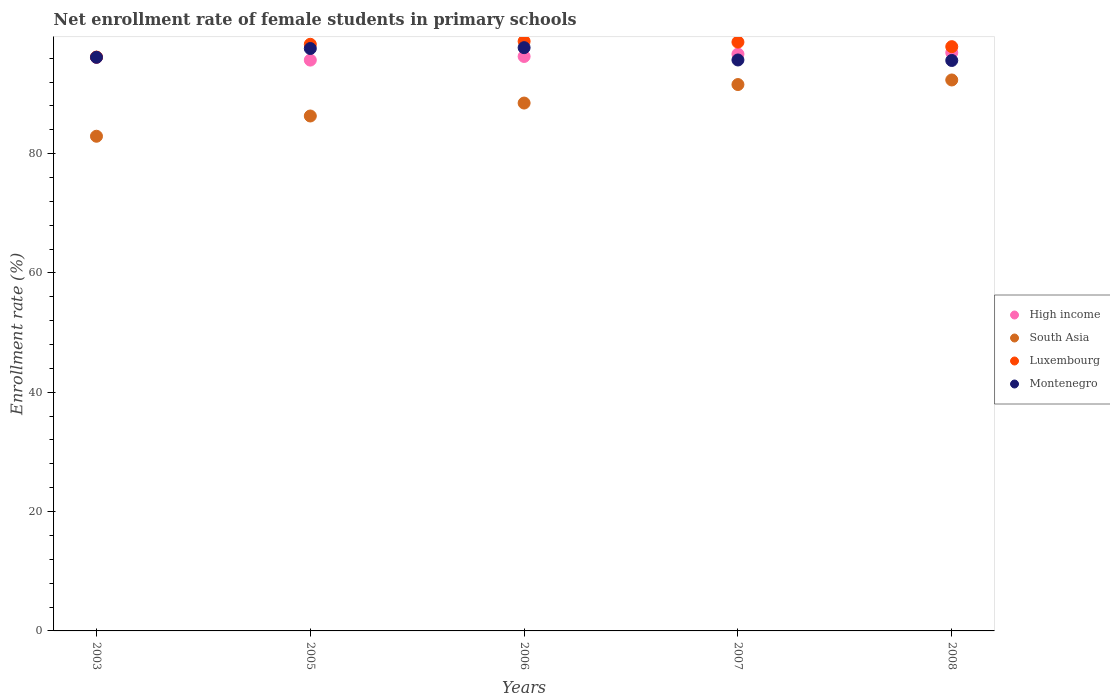How many different coloured dotlines are there?
Offer a very short reply. 4. Is the number of dotlines equal to the number of legend labels?
Your response must be concise. Yes. What is the net enrollment rate of female students in primary schools in Montenegro in 2008?
Ensure brevity in your answer.  95.61. Across all years, what is the maximum net enrollment rate of female students in primary schools in High income?
Your answer should be very brief. 96.92. Across all years, what is the minimum net enrollment rate of female students in primary schools in Montenegro?
Offer a terse response. 95.61. What is the total net enrollment rate of female students in primary schools in High income in the graph?
Your answer should be compact. 481.69. What is the difference between the net enrollment rate of female students in primary schools in Luxembourg in 2003 and that in 2006?
Provide a short and direct response. -2.64. What is the difference between the net enrollment rate of female students in primary schools in High income in 2006 and the net enrollment rate of female students in primary schools in Montenegro in 2007?
Provide a short and direct response. 0.59. What is the average net enrollment rate of female students in primary schools in Montenegro per year?
Your response must be concise. 96.56. In the year 2007, what is the difference between the net enrollment rate of female students in primary schools in Luxembourg and net enrollment rate of female students in primary schools in High income?
Offer a very short reply. 2.01. What is the ratio of the net enrollment rate of female students in primary schools in Luxembourg in 2006 to that in 2007?
Your answer should be compact. 1. Is the net enrollment rate of female students in primary schools in Montenegro in 2006 less than that in 2007?
Give a very brief answer. No. Is the difference between the net enrollment rate of female students in primary schools in Luxembourg in 2005 and 2006 greater than the difference between the net enrollment rate of female students in primary schools in High income in 2005 and 2006?
Make the answer very short. Yes. What is the difference between the highest and the second highest net enrollment rate of female students in primary schools in South Asia?
Offer a terse response. 0.77. What is the difference between the highest and the lowest net enrollment rate of female students in primary schools in High income?
Make the answer very short. 1.25. Is the sum of the net enrollment rate of female students in primary schools in Luxembourg in 2006 and 2008 greater than the maximum net enrollment rate of female students in primary schools in High income across all years?
Give a very brief answer. Yes. Is it the case that in every year, the sum of the net enrollment rate of female students in primary schools in Montenegro and net enrollment rate of female students in primary schools in High income  is greater than the sum of net enrollment rate of female students in primary schools in Luxembourg and net enrollment rate of female students in primary schools in South Asia?
Your answer should be very brief. Yes. Does the net enrollment rate of female students in primary schools in Montenegro monotonically increase over the years?
Provide a short and direct response. No. How many dotlines are there?
Your answer should be very brief. 4. What is the difference between two consecutive major ticks on the Y-axis?
Keep it short and to the point. 20. Are the values on the major ticks of Y-axis written in scientific E-notation?
Provide a succinct answer. No. Does the graph contain any zero values?
Offer a very short reply. No. Does the graph contain grids?
Make the answer very short. No. Where does the legend appear in the graph?
Keep it short and to the point. Center right. What is the title of the graph?
Provide a short and direct response. Net enrollment rate of female students in primary schools. Does "Guinea-Bissau" appear as one of the legend labels in the graph?
Your answer should be very brief. No. What is the label or title of the X-axis?
Offer a terse response. Years. What is the label or title of the Y-axis?
Keep it short and to the point. Enrollment rate (%). What is the Enrollment rate (%) of High income in 2003?
Provide a short and direct response. 96.13. What is the Enrollment rate (%) of South Asia in 2003?
Your answer should be very brief. 82.91. What is the Enrollment rate (%) of Luxembourg in 2003?
Offer a terse response. 96.18. What is the Enrollment rate (%) in Montenegro in 2003?
Provide a succinct answer. 96.14. What is the Enrollment rate (%) in High income in 2005?
Provide a short and direct response. 95.67. What is the Enrollment rate (%) of South Asia in 2005?
Offer a terse response. 86.3. What is the Enrollment rate (%) in Luxembourg in 2005?
Make the answer very short. 98.32. What is the Enrollment rate (%) of Montenegro in 2005?
Your answer should be very brief. 97.61. What is the Enrollment rate (%) of High income in 2006?
Provide a succinct answer. 96.28. What is the Enrollment rate (%) of South Asia in 2006?
Keep it short and to the point. 88.47. What is the Enrollment rate (%) in Luxembourg in 2006?
Keep it short and to the point. 98.82. What is the Enrollment rate (%) of Montenegro in 2006?
Provide a short and direct response. 97.76. What is the Enrollment rate (%) of High income in 2007?
Offer a very short reply. 96.68. What is the Enrollment rate (%) in South Asia in 2007?
Offer a terse response. 91.57. What is the Enrollment rate (%) of Luxembourg in 2007?
Offer a very short reply. 98.69. What is the Enrollment rate (%) of Montenegro in 2007?
Make the answer very short. 95.69. What is the Enrollment rate (%) in High income in 2008?
Your answer should be very brief. 96.92. What is the Enrollment rate (%) in South Asia in 2008?
Your answer should be compact. 92.34. What is the Enrollment rate (%) in Luxembourg in 2008?
Give a very brief answer. 97.92. What is the Enrollment rate (%) in Montenegro in 2008?
Provide a succinct answer. 95.61. Across all years, what is the maximum Enrollment rate (%) of High income?
Your answer should be very brief. 96.92. Across all years, what is the maximum Enrollment rate (%) of South Asia?
Offer a terse response. 92.34. Across all years, what is the maximum Enrollment rate (%) of Luxembourg?
Provide a short and direct response. 98.82. Across all years, what is the maximum Enrollment rate (%) of Montenegro?
Offer a very short reply. 97.76. Across all years, what is the minimum Enrollment rate (%) in High income?
Keep it short and to the point. 95.67. Across all years, what is the minimum Enrollment rate (%) in South Asia?
Give a very brief answer. 82.91. Across all years, what is the minimum Enrollment rate (%) of Luxembourg?
Provide a short and direct response. 96.18. Across all years, what is the minimum Enrollment rate (%) of Montenegro?
Provide a short and direct response. 95.61. What is the total Enrollment rate (%) in High income in the graph?
Give a very brief answer. 481.69. What is the total Enrollment rate (%) of South Asia in the graph?
Your response must be concise. 441.6. What is the total Enrollment rate (%) in Luxembourg in the graph?
Offer a very short reply. 489.93. What is the total Enrollment rate (%) in Montenegro in the graph?
Make the answer very short. 482.81. What is the difference between the Enrollment rate (%) of High income in 2003 and that in 2005?
Offer a terse response. 0.46. What is the difference between the Enrollment rate (%) in South Asia in 2003 and that in 2005?
Offer a very short reply. -3.39. What is the difference between the Enrollment rate (%) in Luxembourg in 2003 and that in 2005?
Provide a short and direct response. -2.14. What is the difference between the Enrollment rate (%) of Montenegro in 2003 and that in 2005?
Provide a short and direct response. -1.47. What is the difference between the Enrollment rate (%) of High income in 2003 and that in 2006?
Offer a very short reply. -0.15. What is the difference between the Enrollment rate (%) of South Asia in 2003 and that in 2006?
Provide a succinct answer. -5.56. What is the difference between the Enrollment rate (%) of Luxembourg in 2003 and that in 2006?
Your answer should be very brief. -2.64. What is the difference between the Enrollment rate (%) in Montenegro in 2003 and that in 2006?
Ensure brevity in your answer.  -1.61. What is the difference between the Enrollment rate (%) in High income in 2003 and that in 2007?
Your answer should be very brief. -0.55. What is the difference between the Enrollment rate (%) of South Asia in 2003 and that in 2007?
Your response must be concise. -8.67. What is the difference between the Enrollment rate (%) in Luxembourg in 2003 and that in 2007?
Offer a very short reply. -2.51. What is the difference between the Enrollment rate (%) in Montenegro in 2003 and that in 2007?
Give a very brief answer. 0.45. What is the difference between the Enrollment rate (%) in High income in 2003 and that in 2008?
Provide a short and direct response. -0.78. What is the difference between the Enrollment rate (%) of South Asia in 2003 and that in 2008?
Give a very brief answer. -9.43. What is the difference between the Enrollment rate (%) in Luxembourg in 2003 and that in 2008?
Offer a very short reply. -1.75. What is the difference between the Enrollment rate (%) of Montenegro in 2003 and that in 2008?
Keep it short and to the point. 0.53. What is the difference between the Enrollment rate (%) of High income in 2005 and that in 2006?
Provide a succinct answer. -0.61. What is the difference between the Enrollment rate (%) in South Asia in 2005 and that in 2006?
Offer a terse response. -2.17. What is the difference between the Enrollment rate (%) of Luxembourg in 2005 and that in 2006?
Keep it short and to the point. -0.5. What is the difference between the Enrollment rate (%) of Montenegro in 2005 and that in 2006?
Provide a short and direct response. -0.14. What is the difference between the Enrollment rate (%) of High income in 2005 and that in 2007?
Provide a short and direct response. -1.01. What is the difference between the Enrollment rate (%) of South Asia in 2005 and that in 2007?
Give a very brief answer. -5.27. What is the difference between the Enrollment rate (%) of Luxembourg in 2005 and that in 2007?
Your response must be concise. -0.37. What is the difference between the Enrollment rate (%) of Montenegro in 2005 and that in 2007?
Offer a very short reply. 1.92. What is the difference between the Enrollment rate (%) in High income in 2005 and that in 2008?
Offer a very short reply. -1.25. What is the difference between the Enrollment rate (%) of South Asia in 2005 and that in 2008?
Your response must be concise. -6.04. What is the difference between the Enrollment rate (%) in Luxembourg in 2005 and that in 2008?
Provide a short and direct response. 0.4. What is the difference between the Enrollment rate (%) of Montenegro in 2005 and that in 2008?
Keep it short and to the point. 2. What is the difference between the Enrollment rate (%) in High income in 2006 and that in 2007?
Make the answer very short. -0.4. What is the difference between the Enrollment rate (%) of South Asia in 2006 and that in 2007?
Keep it short and to the point. -3.1. What is the difference between the Enrollment rate (%) of Luxembourg in 2006 and that in 2007?
Your answer should be very brief. 0.13. What is the difference between the Enrollment rate (%) of Montenegro in 2006 and that in 2007?
Offer a terse response. 2.06. What is the difference between the Enrollment rate (%) in High income in 2006 and that in 2008?
Keep it short and to the point. -0.64. What is the difference between the Enrollment rate (%) in South Asia in 2006 and that in 2008?
Provide a succinct answer. -3.87. What is the difference between the Enrollment rate (%) of Luxembourg in 2006 and that in 2008?
Your answer should be compact. 0.89. What is the difference between the Enrollment rate (%) in Montenegro in 2006 and that in 2008?
Provide a short and direct response. 2.15. What is the difference between the Enrollment rate (%) of High income in 2007 and that in 2008?
Your response must be concise. -0.24. What is the difference between the Enrollment rate (%) in South Asia in 2007 and that in 2008?
Provide a succinct answer. -0.77. What is the difference between the Enrollment rate (%) in Luxembourg in 2007 and that in 2008?
Your answer should be compact. 0.76. What is the difference between the Enrollment rate (%) of Montenegro in 2007 and that in 2008?
Offer a very short reply. 0.08. What is the difference between the Enrollment rate (%) in High income in 2003 and the Enrollment rate (%) in South Asia in 2005?
Your answer should be compact. 9.83. What is the difference between the Enrollment rate (%) in High income in 2003 and the Enrollment rate (%) in Luxembourg in 2005?
Offer a very short reply. -2.19. What is the difference between the Enrollment rate (%) of High income in 2003 and the Enrollment rate (%) of Montenegro in 2005?
Your answer should be very brief. -1.48. What is the difference between the Enrollment rate (%) in South Asia in 2003 and the Enrollment rate (%) in Luxembourg in 2005?
Offer a terse response. -15.41. What is the difference between the Enrollment rate (%) in South Asia in 2003 and the Enrollment rate (%) in Montenegro in 2005?
Your answer should be very brief. -14.7. What is the difference between the Enrollment rate (%) of Luxembourg in 2003 and the Enrollment rate (%) of Montenegro in 2005?
Your answer should be compact. -1.44. What is the difference between the Enrollment rate (%) in High income in 2003 and the Enrollment rate (%) in South Asia in 2006?
Give a very brief answer. 7.66. What is the difference between the Enrollment rate (%) of High income in 2003 and the Enrollment rate (%) of Luxembourg in 2006?
Give a very brief answer. -2.68. What is the difference between the Enrollment rate (%) in High income in 2003 and the Enrollment rate (%) in Montenegro in 2006?
Make the answer very short. -1.62. What is the difference between the Enrollment rate (%) of South Asia in 2003 and the Enrollment rate (%) of Luxembourg in 2006?
Give a very brief answer. -15.91. What is the difference between the Enrollment rate (%) in South Asia in 2003 and the Enrollment rate (%) in Montenegro in 2006?
Your answer should be compact. -14.85. What is the difference between the Enrollment rate (%) in Luxembourg in 2003 and the Enrollment rate (%) in Montenegro in 2006?
Make the answer very short. -1.58. What is the difference between the Enrollment rate (%) of High income in 2003 and the Enrollment rate (%) of South Asia in 2007?
Make the answer very short. 4.56. What is the difference between the Enrollment rate (%) in High income in 2003 and the Enrollment rate (%) in Luxembourg in 2007?
Keep it short and to the point. -2.55. What is the difference between the Enrollment rate (%) of High income in 2003 and the Enrollment rate (%) of Montenegro in 2007?
Offer a terse response. 0.44. What is the difference between the Enrollment rate (%) of South Asia in 2003 and the Enrollment rate (%) of Luxembourg in 2007?
Provide a succinct answer. -15.78. What is the difference between the Enrollment rate (%) in South Asia in 2003 and the Enrollment rate (%) in Montenegro in 2007?
Your answer should be compact. -12.78. What is the difference between the Enrollment rate (%) of Luxembourg in 2003 and the Enrollment rate (%) of Montenegro in 2007?
Provide a succinct answer. 0.49. What is the difference between the Enrollment rate (%) in High income in 2003 and the Enrollment rate (%) in South Asia in 2008?
Your response must be concise. 3.79. What is the difference between the Enrollment rate (%) of High income in 2003 and the Enrollment rate (%) of Luxembourg in 2008?
Provide a short and direct response. -1.79. What is the difference between the Enrollment rate (%) of High income in 2003 and the Enrollment rate (%) of Montenegro in 2008?
Make the answer very short. 0.53. What is the difference between the Enrollment rate (%) in South Asia in 2003 and the Enrollment rate (%) in Luxembourg in 2008?
Ensure brevity in your answer.  -15.02. What is the difference between the Enrollment rate (%) in South Asia in 2003 and the Enrollment rate (%) in Montenegro in 2008?
Ensure brevity in your answer.  -12.7. What is the difference between the Enrollment rate (%) in Luxembourg in 2003 and the Enrollment rate (%) in Montenegro in 2008?
Your response must be concise. 0.57. What is the difference between the Enrollment rate (%) in High income in 2005 and the Enrollment rate (%) in South Asia in 2006?
Provide a short and direct response. 7.2. What is the difference between the Enrollment rate (%) in High income in 2005 and the Enrollment rate (%) in Luxembourg in 2006?
Keep it short and to the point. -3.15. What is the difference between the Enrollment rate (%) in High income in 2005 and the Enrollment rate (%) in Montenegro in 2006?
Offer a terse response. -2.09. What is the difference between the Enrollment rate (%) in South Asia in 2005 and the Enrollment rate (%) in Luxembourg in 2006?
Your answer should be compact. -12.52. What is the difference between the Enrollment rate (%) in South Asia in 2005 and the Enrollment rate (%) in Montenegro in 2006?
Offer a terse response. -11.45. What is the difference between the Enrollment rate (%) in Luxembourg in 2005 and the Enrollment rate (%) in Montenegro in 2006?
Ensure brevity in your answer.  0.57. What is the difference between the Enrollment rate (%) of High income in 2005 and the Enrollment rate (%) of South Asia in 2007?
Ensure brevity in your answer.  4.1. What is the difference between the Enrollment rate (%) in High income in 2005 and the Enrollment rate (%) in Luxembourg in 2007?
Offer a very short reply. -3.02. What is the difference between the Enrollment rate (%) of High income in 2005 and the Enrollment rate (%) of Montenegro in 2007?
Provide a succinct answer. -0.02. What is the difference between the Enrollment rate (%) of South Asia in 2005 and the Enrollment rate (%) of Luxembourg in 2007?
Offer a very short reply. -12.38. What is the difference between the Enrollment rate (%) of South Asia in 2005 and the Enrollment rate (%) of Montenegro in 2007?
Ensure brevity in your answer.  -9.39. What is the difference between the Enrollment rate (%) of Luxembourg in 2005 and the Enrollment rate (%) of Montenegro in 2007?
Offer a terse response. 2.63. What is the difference between the Enrollment rate (%) in High income in 2005 and the Enrollment rate (%) in South Asia in 2008?
Your answer should be compact. 3.33. What is the difference between the Enrollment rate (%) in High income in 2005 and the Enrollment rate (%) in Luxembourg in 2008?
Your response must be concise. -2.25. What is the difference between the Enrollment rate (%) in High income in 2005 and the Enrollment rate (%) in Montenegro in 2008?
Give a very brief answer. 0.06. What is the difference between the Enrollment rate (%) of South Asia in 2005 and the Enrollment rate (%) of Luxembourg in 2008?
Offer a very short reply. -11.62. What is the difference between the Enrollment rate (%) in South Asia in 2005 and the Enrollment rate (%) in Montenegro in 2008?
Offer a terse response. -9.31. What is the difference between the Enrollment rate (%) in Luxembourg in 2005 and the Enrollment rate (%) in Montenegro in 2008?
Offer a very short reply. 2.71. What is the difference between the Enrollment rate (%) of High income in 2006 and the Enrollment rate (%) of South Asia in 2007?
Keep it short and to the point. 4.71. What is the difference between the Enrollment rate (%) of High income in 2006 and the Enrollment rate (%) of Luxembourg in 2007?
Offer a terse response. -2.41. What is the difference between the Enrollment rate (%) of High income in 2006 and the Enrollment rate (%) of Montenegro in 2007?
Your answer should be compact. 0.59. What is the difference between the Enrollment rate (%) of South Asia in 2006 and the Enrollment rate (%) of Luxembourg in 2007?
Give a very brief answer. -10.21. What is the difference between the Enrollment rate (%) of South Asia in 2006 and the Enrollment rate (%) of Montenegro in 2007?
Offer a terse response. -7.22. What is the difference between the Enrollment rate (%) of Luxembourg in 2006 and the Enrollment rate (%) of Montenegro in 2007?
Keep it short and to the point. 3.13. What is the difference between the Enrollment rate (%) in High income in 2006 and the Enrollment rate (%) in South Asia in 2008?
Give a very brief answer. 3.94. What is the difference between the Enrollment rate (%) in High income in 2006 and the Enrollment rate (%) in Luxembourg in 2008?
Provide a short and direct response. -1.64. What is the difference between the Enrollment rate (%) in High income in 2006 and the Enrollment rate (%) in Montenegro in 2008?
Give a very brief answer. 0.67. What is the difference between the Enrollment rate (%) in South Asia in 2006 and the Enrollment rate (%) in Luxembourg in 2008?
Ensure brevity in your answer.  -9.45. What is the difference between the Enrollment rate (%) in South Asia in 2006 and the Enrollment rate (%) in Montenegro in 2008?
Make the answer very short. -7.14. What is the difference between the Enrollment rate (%) in Luxembourg in 2006 and the Enrollment rate (%) in Montenegro in 2008?
Ensure brevity in your answer.  3.21. What is the difference between the Enrollment rate (%) in High income in 2007 and the Enrollment rate (%) in South Asia in 2008?
Make the answer very short. 4.34. What is the difference between the Enrollment rate (%) of High income in 2007 and the Enrollment rate (%) of Luxembourg in 2008?
Your response must be concise. -1.24. What is the difference between the Enrollment rate (%) of High income in 2007 and the Enrollment rate (%) of Montenegro in 2008?
Your response must be concise. 1.07. What is the difference between the Enrollment rate (%) of South Asia in 2007 and the Enrollment rate (%) of Luxembourg in 2008?
Provide a succinct answer. -6.35. What is the difference between the Enrollment rate (%) of South Asia in 2007 and the Enrollment rate (%) of Montenegro in 2008?
Offer a very short reply. -4.03. What is the difference between the Enrollment rate (%) of Luxembourg in 2007 and the Enrollment rate (%) of Montenegro in 2008?
Ensure brevity in your answer.  3.08. What is the average Enrollment rate (%) in High income per year?
Keep it short and to the point. 96.34. What is the average Enrollment rate (%) in South Asia per year?
Your response must be concise. 88.32. What is the average Enrollment rate (%) in Luxembourg per year?
Your response must be concise. 97.99. What is the average Enrollment rate (%) of Montenegro per year?
Provide a short and direct response. 96.56. In the year 2003, what is the difference between the Enrollment rate (%) of High income and Enrollment rate (%) of South Asia?
Your response must be concise. 13.23. In the year 2003, what is the difference between the Enrollment rate (%) of High income and Enrollment rate (%) of Luxembourg?
Give a very brief answer. -0.04. In the year 2003, what is the difference between the Enrollment rate (%) in High income and Enrollment rate (%) in Montenegro?
Give a very brief answer. -0.01. In the year 2003, what is the difference between the Enrollment rate (%) of South Asia and Enrollment rate (%) of Luxembourg?
Provide a short and direct response. -13.27. In the year 2003, what is the difference between the Enrollment rate (%) in South Asia and Enrollment rate (%) in Montenegro?
Give a very brief answer. -13.23. In the year 2003, what is the difference between the Enrollment rate (%) in Luxembourg and Enrollment rate (%) in Montenegro?
Provide a short and direct response. 0.04. In the year 2005, what is the difference between the Enrollment rate (%) of High income and Enrollment rate (%) of South Asia?
Ensure brevity in your answer.  9.37. In the year 2005, what is the difference between the Enrollment rate (%) in High income and Enrollment rate (%) in Luxembourg?
Offer a very short reply. -2.65. In the year 2005, what is the difference between the Enrollment rate (%) of High income and Enrollment rate (%) of Montenegro?
Provide a succinct answer. -1.94. In the year 2005, what is the difference between the Enrollment rate (%) in South Asia and Enrollment rate (%) in Luxembourg?
Make the answer very short. -12.02. In the year 2005, what is the difference between the Enrollment rate (%) of South Asia and Enrollment rate (%) of Montenegro?
Give a very brief answer. -11.31. In the year 2005, what is the difference between the Enrollment rate (%) of Luxembourg and Enrollment rate (%) of Montenegro?
Your answer should be compact. 0.71. In the year 2006, what is the difference between the Enrollment rate (%) in High income and Enrollment rate (%) in South Asia?
Your response must be concise. 7.81. In the year 2006, what is the difference between the Enrollment rate (%) of High income and Enrollment rate (%) of Luxembourg?
Offer a very short reply. -2.54. In the year 2006, what is the difference between the Enrollment rate (%) of High income and Enrollment rate (%) of Montenegro?
Your answer should be compact. -1.47. In the year 2006, what is the difference between the Enrollment rate (%) in South Asia and Enrollment rate (%) in Luxembourg?
Offer a terse response. -10.35. In the year 2006, what is the difference between the Enrollment rate (%) in South Asia and Enrollment rate (%) in Montenegro?
Your answer should be very brief. -9.28. In the year 2006, what is the difference between the Enrollment rate (%) of Luxembourg and Enrollment rate (%) of Montenegro?
Make the answer very short. 1.06. In the year 2007, what is the difference between the Enrollment rate (%) of High income and Enrollment rate (%) of South Asia?
Provide a succinct answer. 5.11. In the year 2007, what is the difference between the Enrollment rate (%) of High income and Enrollment rate (%) of Luxembourg?
Offer a very short reply. -2.01. In the year 2007, what is the difference between the Enrollment rate (%) in High income and Enrollment rate (%) in Montenegro?
Provide a short and direct response. 0.99. In the year 2007, what is the difference between the Enrollment rate (%) in South Asia and Enrollment rate (%) in Luxembourg?
Make the answer very short. -7.11. In the year 2007, what is the difference between the Enrollment rate (%) of South Asia and Enrollment rate (%) of Montenegro?
Provide a short and direct response. -4.12. In the year 2007, what is the difference between the Enrollment rate (%) in Luxembourg and Enrollment rate (%) in Montenegro?
Offer a terse response. 3. In the year 2008, what is the difference between the Enrollment rate (%) of High income and Enrollment rate (%) of South Asia?
Ensure brevity in your answer.  4.58. In the year 2008, what is the difference between the Enrollment rate (%) in High income and Enrollment rate (%) in Luxembourg?
Keep it short and to the point. -1.01. In the year 2008, what is the difference between the Enrollment rate (%) of High income and Enrollment rate (%) of Montenegro?
Your answer should be compact. 1.31. In the year 2008, what is the difference between the Enrollment rate (%) in South Asia and Enrollment rate (%) in Luxembourg?
Ensure brevity in your answer.  -5.58. In the year 2008, what is the difference between the Enrollment rate (%) in South Asia and Enrollment rate (%) in Montenegro?
Your answer should be compact. -3.27. In the year 2008, what is the difference between the Enrollment rate (%) in Luxembourg and Enrollment rate (%) in Montenegro?
Offer a terse response. 2.32. What is the ratio of the Enrollment rate (%) of South Asia in 2003 to that in 2005?
Provide a succinct answer. 0.96. What is the ratio of the Enrollment rate (%) of Luxembourg in 2003 to that in 2005?
Your answer should be compact. 0.98. What is the ratio of the Enrollment rate (%) in Montenegro in 2003 to that in 2005?
Give a very brief answer. 0.98. What is the ratio of the Enrollment rate (%) of South Asia in 2003 to that in 2006?
Offer a terse response. 0.94. What is the ratio of the Enrollment rate (%) in Luxembourg in 2003 to that in 2006?
Your response must be concise. 0.97. What is the ratio of the Enrollment rate (%) in Montenegro in 2003 to that in 2006?
Your answer should be very brief. 0.98. What is the ratio of the Enrollment rate (%) in High income in 2003 to that in 2007?
Make the answer very short. 0.99. What is the ratio of the Enrollment rate (%) of South Asia in 2003 to that in 2007?
Provide a succinct answer. 0.91. What is the ratio of the Enrollment rate (%) in Luxembourg in 2003 to that in 2007?
Ensure brevity in your answer.  0.97. What is the ratio of the Enrollment rate (%) of South Asia in 2003 to that in 2008?
Offer a terse response. 0.9. What is the ratio of the Enrollment rate (%) of Luxembourg in 2003 to that in 2008?
Keep it short and to the point. 0.98. What is the ratio of the Enrollment rate (%) in Montenegro in 2003 to that in 2008?
Offer a very short reply. 1.01. What is the ratio of the Enrollment rate (%) of High income in 2005 to that in 2006?
Ensure brevity in your answer.  0.99. What is the ratio of the Enrollment rate (%) in South Asia in 2005 to that in 2006?
Ensure brevity in your answer.  0.98. What is the ratio of the Enrollment rate (%) of Luxembourg in 2005 to that in 2006?
Give a very brief answer. 0.99. What is the ratio of the Enrollment rate (%) in Montenegro in 2005 to that in 2006?
Offer a terse response. 1. What is the ratio of the Enrollment rate (%) of South Asia in 2005 to that in 2007?
Your answer should be compact. 0.94. What is the ratio of the Enrollment rate (%) of Montenegro in 2005 to that in 2007?
Your answer should be very brief. 1.02. What is the ratio of the Enrollment rate (%) of High income in 2005 to that in 2008?
Your answer should be very brief. 0.99. What is the ratio of the Enrollment rate (%) in South Asia in 2005 to that in 2008?
Keep it short and to the point. 0.93. What is the ratio of the Enrollment rate (%) of Luxembourg in 2005 to that in 2008?
Offer a very short reply. 1. What is the ratio of the Enrollment rate (%) of South Asia in 2006 to that in 2007?
Give a very brief answer. 0.97. What is the ratio of the Enrollment rate (%) in Montenegro in 2006 to that in 2007?
Your answer should be compact. 1.02. What is the ratio of the Enrollment rate (%) of High income in 2006 to that in 2008?
Your response must be concise. 0.99. What is the ratio of the Enrollment rate (%) of South Asia in 2006 to that in 2008?
Your answer should be compact. 0.96. What is the ratio of the Enrollment rate (%) of Luxembourg in 2006 to that in 2008?
Make the answer very short. 1.01. What is the ratio of the Enrollment rate (%) of Montenegro in 2006 to that in 2008?
Offer a very short reply. 1.02. What is the ratio of the Enrollment rate (%) of South Asia in 2007 to that in 2008?
Your response must be concise. 0.99. What is the ratio of the Enrollment rate (%) of Montenegro in 2007 to that in 2008?
Your answer should be very brief. 1. What is the difference between the highest and the second highest Enrollment rate (%) in High income?
Give a very brief answer. 0.24. What is the difference between the highest and the second highest Enrollment rate (%) of South Asia?
Offer a terse response. 0.77. What is the difference between the highest and the second highest Enrollment rate (%) in Luxembourg?
Your response must be concise. 0.13. What is the difference between the highest and the second highest Enrollment rate (%) in Montenegro?
Offer a terse response. 0.14. What is the difference between the highest and the lowest Enrollment rate (%) of High income?
Your answer should be compact. 1.25. What is the difference between the highest and the lowest Enrollment rate (%) of South Asia?
Offer a very short reply. 9.43. What is the difference between the highest and the lowest Enrollment rate (%) in Luxembourg?
Offer a terse response. 2.64. What is the difference between the highest and the lowest Enrollment rate (%) in Montenegro?
Your response must be concise. 2.15. 